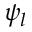<formula> <loc_0><loc_0><loc_500><loc_500>\psi _ { l }</formula> 